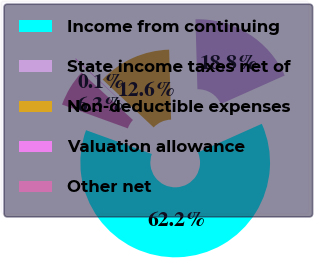Convert chart. <chart><loc_0><loc_0><loc_500><loc_500><pie_chart><fcel>Income from continuing<fcel>State income taxes net of<fcel>Non-deductible expenses<fcel>Valuation allowance<fcel>Other net<nl><fcel>62.21%<fcel>18.76%<fcel>12.55%<fcel>0.14%<fcel>6.34%<nl></chart> 